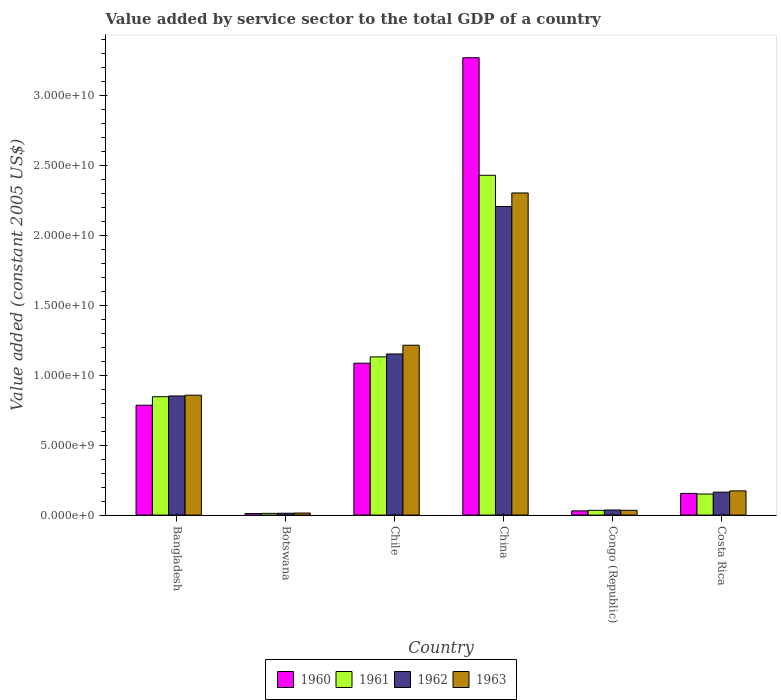How many different coloured bars are there?
Your answer should be compact. 4. How many groups of bars are there?
Provide a succinct answer. 6. Are the number of bars per tick equal to the number of legend labels?
Make the answer very short. Yes. In how many cases, is the number of bars for a given country not equal to the number of legend labels?
Give a very brief answer. 0. What is the value added by service sector in 1963 in Costa Rica?
Provide a short and direct response. 1.73e+09. Across all countries, what is the maximum value added by service sector in 1962?
Your answer should be compact. 2.21e+1. Across all countries, what is the minimum value added by service sector in 1961?
Ensure brevity in your answer.  1.22e+08. In which country was the value added by service sector in 1960 minimum?
Your answer should be very brief. Botswana. What is the total value added by service sector in 1960 in the graph?
Your response must be concise. 5.34e+1. What is the difference between the value added by service sector in 1960 in China and that in Congo (Republic)?
Keep it short and to the point. 3.24e+1. What is the difference between the value added by service sector in 1962 in Chile and the value added by service sector in 1963 in Costa Rica?
Offer a very short reply. 9.80e+09. What is the average value added by service sector in 1961 per country?
Give a very brief answer. 7.68e+09. What is the difference between the value added by service sector of/in 1963 and value added by service sector of/in 1960 in Congo (Republic)?
Ensure brevity in your answer.  4.05e+07. What is the ratio of the value added by service sector in 1960 in Chile to that in China?
Make the answer very short. 0.33. What is the difference between the highest and the second highest value added by service sector in 1960?
Your answer should be compact. -2.19e+1. What is the difference between the highest and the lowest value added by service sector in 1963?
Your answer should be very brief. 2.29e+1. In how many countries, is the value added by service sector in 1960 greater than the average value added by service sector in 1960 taken over all countries?
Provide a succinct answer. 2. Is it the case that in every country, the sum of the value added by service sector in 1962 and value added by service sector in 1963 is greater than the sum of value added by service sector in 1960 and value added by service sector in 1961?
Your answer should be very brief. No. What is the difference between two consecutive major ticks on the Y-axis?
Give a very brief answer. 5.00e+09. Are the values on the major ticks of Y-axis written in scientific E-notation?
Offer a very short reply. Yes. Does the graph contain any zero values?
Your response must be concise. No. Does the graph contain grids?
Your response must be concise. No. Where does the legend appear in the graph?
Make the answer very short. Bottom center. What is the title of the graph?
Offer a terse response. Value added by service sector to the total GDP of a country. Does "1999" appear as one of the legend labels in the graph?
Keep it short and to the point. No. What is the label or title of the Y-axis?
Offer a very short reply. Value added (constant 2005 US$). What is the Value added (constant 2005 US$) of 1960 in Bangladesh?
Your answer should be very brief. 7.86e+09. What is the Value added (constant 2005 US$) in 1961 in Bangladesh?
Make the answer very short. 8.47e+09. What is the Value added (constant 2005 US$) of 1962 in Bangladesh?
Your answer should be compact. 8.52e+09. What is the Value added (constant 2005 US$) of 1963 in Bangladesh?
Your answer should be very brief. 8.58e+09. What is the Value added (constant 2005 US$) in 1960 in Botswana?
Provide a short and direct response. 1.11e+08. What is the Value added (constant 2005 US$) in 1961 in Botswana?
Keep it short and to the point. 1.22e+08. What is the Value added (constant 2005 US$) in 1962 in Botswana?
Provide a succinct answer. 1.32e+08. What is the Value added (constant 2005 US$) of 1963 in Botswana?
Offer a terse response. 1.45e+08. What is the Value added (constant 2005 US$) in 1960 in Chile?
Make the answer very short. 1.09e+1. What is the Value added (constant 2005 US$) of 1961 in Chile?
Offer a terse response. 1.13e+1. What is the Value added (constant 2005 US$) of 1962 in Chile?
Give a very brief answer. 1.15e+1. What is the Value added (constant 2005 US$) in 1963 in Chile?
Make the answer very short. 1.22e+1. What is the Value added (constant 2005 US$) in 1960 in China?
Give a very brief answer. 3.27e+1. What is the Value added (constant 2005 US$) in 1961 in China?
Keep it short and to the point. 2.43e+1. What is the Value added (constant 2005 US$) of 1962 in China?
Make the answer very short. 2.21e+1. What is the Value added (constant 2005 US$) of 1963 in China?
Your response must be concise. 2.30e+1. What is the Value added (constant 2005 US$) of 1960 in Congo (Republic)?
Your response must be concise. 3.02e+08. What is the Value added (constant 2005 US$) of 1961 in Congo (Republic)?
Offer a terse response. 3.39e+08. What is the Value added (constant 2005 US$) of 1962 in Congo (Republic)?
Your response must be concise. 3.64e+08. What is the Value added (constant 2005 US$) in 1963 in Congo (Republic)?
Your response must be concise. 3.42e+08. What is the Value added (constant 2005 US$) of 1960 in Costa Rica?
Provide a short and direct response. 1.55e+09. What is the Value added (constant 2005 US$) of 1961 in Costa Rica?
Make the answer very short. 1.51e+09. What is the Value added (constant 2005 US$) in 1962 in Costa Rica?
Your answer should be very brief. 1.64e+09. What is the Value added (constant 2005 US$) in 1963 in Costa Rica?
Provide a succinct answer. 1.73e+09. Across all countries, what is the maximum Value added (constant 2005 US$) of 1960?
Give a very brief answer. 3.27e+1. Across all countries, what is the maximum Value added (constant 2005 US$) of 1961?
Your answer should be very brief. 2.43e+1. Across all countries, what is the maximum Value added (constant 2005 US$) in 1962?
Your response must be concise. 2.21e+1. Across all countries, what is the maximum Value added (constant 2005 US$) of 1963?
Offer a very short reply. 2.30e+1. Across all countries, what is the minimum Value added (constant 2005 US$) of 1960?
Your response must be concise. 1.11e+08. Across all countries, what is the minimum Value added (constant 2005 US$) in 1961?
Your response must be concise. 1.22e+08. Across all countries, what is the minimum Value added (constant 2005 US$) of 1962?
Provide a short and direct response. 1.32e+08. Across all countries, what is the minimum Value added (constant 2005 US$) in 1963?
Provide a succinct answer. 1.45e+08. What is the total Value added (constant 2005 US$) of 1960 in the graph?
Your answer should be very brief. 5.34e+1. What is the total Value added (constant 2005 US$) of 1961 in the graph?
Provide a short and direct response. 4.61e+1. What is the total Value added (constant 2005 US$) in 1962 in the graph?
Your response must be concise. 4.43e+1. What is the total Value added (constant 2005 US$) in 1963 in the graph?
Ensure brevity in your answer.  4.60e+1. What is the difference between the Value added (constant 2005 US$) in 1960 in Bangladesh and that in Botswana?
Provide a succinct answer. 7.75e+09. What is the difference between the Value added (constant 2005 US$) of 1961 in Bangladesh and that in Botswana?
Provide a succinct answer. 8.35e+09. What is the difference between the Value added (constant 2005 US$) in 1962 in Bangladesh and that in Botswana?
Give a very brief answer. 8.39e+09. What is the difference between the Value added (constant 2005 US$) in 1963 in Bangladesh and that in Botswana?
Offer a terse response. 8.43e+09. What is the difference between the Value added (constant 2005 US$) of 1960 in Bangladesh and that in Chile?
Your answer should be very brief. -3.01e+09. What is the difference between the Value added (constant 2005 US$) in 1961 in Bangladesh and that in Chile?
Make the answer very short. -2.85e+09. What is the difference between the Value added (constant 2005 US$) of 1962 in Bangladesh and that in Chile?
Ensure brevity in your answer.  -3.00e+09. What is the difference between the Value added (constant 2005 US$) in 1963 in Bangladesh and that in Chile?
Your answer should be very brief. -3.58e+09. What is the difference between the Value added (constant 2005 US$) of 1960 in Bangladesh and that in China?
Your answer should be very brief. -2.49e+1. What is the difference between the Value added (constant 2005 US$) in 1961 in Bangladesh and that in China?
Provide a short and direct response. -1.58e+1. What is the difference between the Value added (constant 2005 US$) in 1962 in Bangladesh and that in China?
Make the answer very short. -1.36e+1. What is the difference between the Value added (constant 2005 US$) in 1963 in Bangladesh and that in China?
Offer a very short reply. -1.45e+1. What is the difference between the Value added (constant 2005 US$) in 1960 in Bangladesh and that in Congo (Republic)?
Provide a short and direct response. 7.56e+09. What is the difference between the Value added (constant 2005 US$) in 1961 in Bangladesh and that in Congo (Republic)?
Provide a succinct answer. 8.13e+09. What is the difference between the Value added (constant 2005 US$) of 1962 in Bangladesh and that in Congo (Republic)?
Offer a very short reply. 8.16e+09. What is the difference between the Value added (constant 2005 US$) in 1963 in Bangladesh and that in Congo (Republic)?
Provide a succinct answer. 8.24e+09. What is the difference between the Value added (constant 2005 US$) in 1960 in Bangladesh and that in Costa Rica?
Keep it short and to the point. 6.31e+09. What is the difference between the Value added (constant 2005 US$) in 1961 in Bangladesh and that in Costa Rica?
Give a very brief answer. 6.96e+09. What is the difference between the Value added (constant 2005 US$) of 1962 in Bangladesh and that in Costa Rica?
Keep it short and to the point. 6.88e+09. What is the difference between the Value added (constant 2005 US$) in 1963 in Bangladesh and that in Costa Rica?
Offer a very short reply. 6.85e+09. What is the difference between the Value added (constant 2005 US$) in 1960 in Botswana and that in Chile?
Ensure brevity in your answer.  -1.08e+1. What is the difference between the Value added (constant 2005 US$) of 1961 in Botswana and that in Chile?
Make the answer very short. -1.12e+1. What is the difference between the Value added (constant 2005 US$) of 1962 in Botswana and that in Chile?
Give a very brief answer. -1.14e+1. What is the difference between the Value added (constant 2005 US$) in 1963 in Botswana and that in Chile?
Provide a short and direct response. -1.20e+1. What is the difference between the Value added (constant 2005 US$) of 1960 in Botswana and that in China?
Provide a short and direct response. -3.26e+1. What is the difference between the Value added (constant 2005 US$) of 1961 in Botswana and that in China?
Give a very brief answer. -2.42e+1. What is the difference between the Value added (constant 2005 US$) in 1962 in Botswana and that in China?
Offer a terse response. -2.19e+1. What is the difference between the Value added (constant 2005 US$) in 1963 in Botswana and that in China?
Keep it short and to the point. -2.29e+1. What is the difference between the Value added (constant 2005 US$) of 1960 in Botswana and that in Congo (Republic)?
Make the answer very short. -1.91e+08. What is the difference between the Value added (constant 2005 US$) of 1961 in Botswana and that in Congo (Republic)?
Your answer should be compact. -2.17e+08. What is the difference between the Value added (constant 2005 US$) of 1962 in Botswana and that in Congo (Republic)?
Provide a short and direct response. -2.32e+08. What is the difference between the Value added (constant 2005 US$) of 1963 in Botswana and that in Congo (Republic)?
Ensure brevity in your answer.  -1.97e+08. What is the difference between the Value added (constant 2005 US$) in 1960 in Botswana and that in Costa Rica?
Offer a very short reply. -1.44e+09. What is the difference between the Value added (constant 2005 US$) in 1961 in Botswana and that in Costa Rica?
Offer a very short reply. -1.38e+09. What is the difference between the Value added (constant 2005 US$) of 1962 in Botswana and that in Costa Rica?
Ensure brevity in your answer.  -1.51e+09. What is the difference between the Value added (constant 2005 US$) in 1963 in Botswana and that in Costa Rica?
Give a very brief answer. -1.59e+09. What is the difference between the Value added (constant 2005 US$) of 1960 in Chile and that in China?
Your response must be concise. -2.19e+1. What is the difference between the Value added (constant 2005 US$) in 1961 in Chile and that in China?
Give a very brief answer. -1.30e+1. What is the difference between the Value added (constant 2005 US$) of 1962 in Chile and that in China?
Make the answer very short. -1.05e+1. What is the difference between the Value added (constant 2005 US$) in 1963 in Chile and that in China?
Your answer should be very brief. -1.09e+1. What is the difference between the Value added (constant 2005 US$) in 1960 in Chile and that in Congo (Republic)?
Offer a terse response. 1.06e+1. What is the difference between the Value added (constant 2005 US$) in 1961 in Chile and that in Congo (Republic)?
Keep it short and to the point. 1.10e+1. What is the difference between the Value added (constant 2005 US$) of 1962 in Chile and that in Congo (Republic)?
Your answer should be very brief. 1.12e+1. What is the difference between the Value added (constant 2005 US$) in 1963 in Chile and that in Congo (Republic)?
Offer a terse response. 1.18e+1. What is the difference between the Value added (constant 2005 US$) in 1960 in Chile and that in Costa Rica?
Offer a terse response. 9.31e+09. What is the difference between the Value added (constant 2005 US$) in 1961 in Chile and that in Costa Rica?
Offer a very short reply. 9.81e+09. What is the difference between the Value added (constant 2005 US$) in 1962 in Chile and that in Costa Rica?
Offer a very short reply. 9.89e+09. What is the difference between the Value added (constant 2005 US$) in 1963 in Chile and that in Costa Rica?
Provide a short and direct response. 1.04e+1. What is the difference between the Value added (constant 2005 US$) of 1960 in China and that in Congo (Republic)?
Offer a very short reply. 3.24e+1. What is the difference between the Value added (constant 2005 US$) in 1961 in China and that in Congo (Republic)?
Make the answer very short. 2.40e+1. What is the difference between the Value added (constant 2005 US$) of 1962 in China and that in Congo (Republic)?
Your answer should be very brief. 2.17e+1. What is the difference between the Value added (constant 2005 US$) of 1963 in China and that in Congo (Republic)?
Your answer should be compact. 2.27e+1. What is the difference between the Value added (constant 2005 US$) in 1960 in China and that in Costa Rica?
Your answer should be very brief. 3.12e+1. What is the difference between the Value added (constant 2005 US$) of 1961 in China and that in Costa Rica?
Offer a terse response. 2.28e+1. What is the difference between the Value added (constant 2005 US$) in 1962 in China and that in Costa Rica?
Keep it short and to the point. 2.04e+1. What is the difference between the Value added (constant 2005 US$) in 1963 in China and that in Costa Rica?
Make the answer very short. 2.13e+1. What is the difference between the Value added (constant 2005 US$) in 1960 in Congo (Republic) and that in Costa Rica?
Your answer should be compact. -1.25e+09. What is the difference between the Value added (constant 2005 US$) of 1961 in Congo (Republic) and that in Costa Rica?
Provide a succinct answer. -1.17e+09. What is the difference between the Value added (constant 2005 US$) in 1962 in Congo (Republic) and that in Costa Rica?
Keep it short and to the point. -1.28e+09. What is the difference between the Value added (constant 2005 US$) in 1963 in Congo (Republic) and that in Costa Rica?
Ensure brevity in your answer.  -1.39e+09. What is the difference between the Value added (constant 2005 US$) in 1960 in Bangladesh and the Value added (constant 2005 US$) in 1961 in Botswana?
Your answer should be compact. 7.74e+09. What is the difference between the Value added (constant 2005 US$) in 1960 in Bangladesh and the Value added (constant 2005 US$) in 1962 in Botswana?
Offer a very short reply. 7.73e+09. What is the difference between the Value added (constant 2005 US$) of 1960 in Bangladesh and the Value added (constant 2005 US$) of 1963 in Botswana?
Your answer should be very brief. 7.72e+09. What is the difference between the Value added (constant 2005 US$) in 1961 in Bangladesh and the Value added (constant 2005 US$) in 1962 in Botswana?
Provide a short and direct response. 8.34e+09. What is the difference between the Value added (constant 2005 US$) of 1961 in Bangladesh and the Value added (constant 2005 US$) of 1963 in Botswana?
Keep it short and to the point. 8.32e+09. What is the difference between the Value added (constant 2005 US$) of 1962 in Bangladesh and the Value added (constant 2005 US$) of 1963 in Botswana?
Provide a succinct answer. 8.38e+09. What is the difference between the Value added (constant 2005 US$) of 1960 in Bangladesh and the Value added (constant 2005 US$) of 1961 in Chile?
Your answer should be compact. -3.46e+09. What is the difference between the Value added (constant 2005 US$) in 1960 in Bangladesh and the Value added (constant 2005 US$) in 1962 in Chile?
Provide a succinct answer. -3.67e+09. What is the difference between the Value added (constant 2005 US$) of 1960 in Bangladesh and the Value added (constant 2005 US$) of 1963 in Chile?
Ensure brevity in your answer.  -4.29e+09. What is the difference between the Value added (constant 2005 US$) of 1961 in Bangladesh and the Value added (constant 2005 US$) of 1962 in Chile?
Provide a succinct answer. -3.06e+09. What is the difference between the Value added (constant 2005 US$) in 1961 in Bangladesh and the Value added (constant 2005 US$) in 1963 in Chile?
Make the answer very short. -3.68e+09. What is the difference between the Value added (constant 2005 US$) in 1962 in Bangladesh and the Value added (constant 2005 US$) in 1963 in Chile?
Ensure brevity in your answer.  -3.63e+09. What is the difference between the Value added (constant 2005 US$) in 1960 in Bangladesh and the Value added (constant 2005 US$) in 1961 in China?
Provide a succinct answer. -1.65e+1. What is the difference between the Value added (constant 2005 US$) of 1960 in Bangladesh and the Value added (constant 2005 US$) of 1962 in China?
Make the answer very short. -1.42e+1. What is the difference between the Value added (constant 2005 US$) in 1960 in Bangladesh and the Value added (constant 2005 US$) in 1963 in China?
Your answer should be very brief. -1.52e+1. What is the difference between the Value added (constant 2005 US$) in 1961 in Bangladesh and the Value added (constant 2005 US$) in 1962 in China?
Offer a very short reply. -1.36e+1. What is the difference between the Value added (constant 2005 US$) of 1961 in Bangladesh and the Value added (constant 2005 US$) of 1963 in China?
Ensure brevity in your answer.  -1.46e+1. What is the difference between the Value added (constant 2005 US$) in 1962 in Bangladesh and the Value added (constant 2005 US$) in 1963 in China?
Make the answer very short. -1.45e+1. What is the difference between the Value added (constant 2005 US$) in 1960 in Bangladesh and the Value added (constant 2005 US$) in 1961 in Congo (Republic)?
Give a very brief answer. 7.52e+09. What is the difference between the Value added (constant 2005 US$) in 1960 in Bangladesh and the Value added (constant 2005 US$) in 1962 in Congo (Republic)?
Make the answer very short. 7.50e+09. What is the difference between the Value added (constant 2005 US$) in 1960 in Bangladesh and the Value added (constant 2005 US$) in 1963 in Congo (Republic)?
Your answer should be very brief. 7.52e+09. What is the difference between the Value added (constant 2005 US$) of 1961 in Bangladesh and the Value added (constant 2005 US$) of 1962 in Congo (Republic)?
Ensure brevity in your answer.  8.11e+09. What is the difference between the Value added (constant 2005 US$) in 1961 in Bangladesh and the Value added (constant 2005 US$) in 1963 in Congo (Republic)?
Offer a terse response. 8.13e+09. What is the difference between the Value added (constant 2005 US$) of 1962 in Bangladesh and the Value added (constant 2005 US$) of 1963 in Congo (Republic)?
Your answer should be very brief. 8.18e+09. What is the difference between the Value added (constant 2005 US$) of 1960 in Bangladesh and the Value added (constant 2005 US$) of 1961 in Costa Rica?
Make the answer very short. 6.36e+09. What is the difference between the Value added (constant 2005 US$) of 1960 in Bangladesh and the Value added (constant 2005 US$) of 1962 in Costa Rica?
Keep it short and to the point. 6.22e+09. What is the difference between the Value added (constant 2005 US$) in 1960 in Bangladesh and the Value added (constant 2005 US$) in 1963 in Costa Rica?
Your answer should be very brief. 6.13e+09. What is the difference between the Value added (constant 2005 US$) of 1961 in Bangladesh and the Value added (constant 2005 US$) of 1962 in Costa Rica?
Offer a terse response. 6.83e+09. What is the difference between the Value added (constant 2005 US$) in 1961 in Bangladesh and the Value added (constant 2005 US$) in 1963 in Costa Rica?
Make the answer very short. 6.74e+09. What is the difference between the Value added (constant 2005 US$) of 1962 in Bangladesh and the Value added (constant 2005 US$) of 1963 in Costa Rica?
Ensure brevity in your answer.  6.79e+09. What is the difference between the Value added (constant 2005 US$) in 1960 in Botswana and the Value added (constant 2005 US$) in 1961 in Chile?
Your response must be concise. -1.12e+1. What is the difference between the Value added (constant 2005 US$) in 1960 in Botswana and the Value added (constant 2005 US$) in 1962 in Chile?
Make the answer very short. -1.14e+1. What is the difference between the Value added (constant 2005 US$) of 1960 in Botswana and the Value added (constant 2005 US$) of 1963 in Chile?
Your answer should be compact. -1.20e+1. What is the difference between the Value added (constant 2005 US$) of 1961 in Botswana and the Value added (constant 2005 US$) of 1962 in Chile?
Offer a very short reply. -1.14e+1. What is the difference between the Value added (constant 2005 US$) in 1961 in Botswana and the Value added (constant 2005 US$) in 1963 in Chile?
Your answer should be very brief. -1.20e+1. What is the difference between the Value added (constant 2005 US$) in 1962 in Botswana and the Value added (constant 2005 US$) in 1963 in Chile?
Your answer should be very brief. -1.20e+1. What is the difference between the Value added (constant 2005 US$) of 1960 in Botswana and the Value added (constant 2005 US$) of 1961 in China?
Keep it short and to the point. -2.42e+1. What is the difference between the Value added (constant 2005 US$) of 1960 in Botswana and the Value added (constant 2005 US$) of 1962 in China?
Give a very brief answer. -2.20e+1. What is the difference between the Value added (constant 2005 US$) of 1960 in Botswana and the Value added (constant 2005 US$) of 1963 in China?
Provide a succinct answer. -2.29e+1. What is the difference between the Value added (constant 2005 US$) in 1961 in Botswana and the Value added (constant 2005 US$) in 1962 in China?
Keep it short and to the point. -2.20e+1. What is the difference between the Value added (constant 2005 US$) in 1961 in Botswana and the Value added (constant 2005 US$) in 1963 in China?
Offer a terse response. -2.29e+1. What is the difference between the Value added (constant 2005 US$) of 1962 in Botswana and the Value added (constant 2005 US$) of 1963 in China?
Ensure brevity in your answer.  -2.29e+1. What is the difference between the Value added (constant 2005 US$) of 1960 in Botswana and the Value added (constant 2005 US$) of 1961 in Congo (Republic)?
Ensure brevity in your answer.  -2.28e+08. What is the difference between the Value added (constant 2005 US$) of 1960 in Botswana and the Value added (constant 2005 US$) of 1962 in Congo (Republic)?
Provide a short and direct response. -2.53e+08. What is the difference between the Value added (constant 2005 US$) of 1960 in Botswana and the Value added (constant 2005 US$) of 1963 in Congo (Republic)?
Keep it short and to the point. -2.31e+08. What is the difference between the Value added (constant 2005 US$) of 1961 in Botswana and the Value added (constant 2005 US$) of 1962 in Congo (Republic)?
Offer a very short reply. -2.42e+08. What is the difference between the Value added (constant 2005 US$) of 1961 in Botswana and the Value added (constant 2005 US$) of 1963 in Congo (Republic)?
Give a very brief answer. -2.20e+08. What is the difference between the Value added (constant 2005 US$) in 1962 in Botswana and the Value added (constant 2005 US$) in 1963 in Congo (Republic)?
Your response must be concise. -2.10e+08. What is the difference between the Value added (constant 2005 US$) in 1960 in Botswana and the Value added (constant 2005 US$) in 1961 in Costa Rica?
Your answer should be very brief. -1.39e+09. What is the difference between the Value added (constant 2005 US$) of 1960 in Botswana and the Value added (constant 2005 US$) of 1962 in Costa Rica?
Your response must be concise. -1.53e+09. What is the difference between the Value added (constant 2005 US$) in 1960 in Botswana and the Value added (constant 2005 US$) in 1963 in Costa Rica?
Provide a short and direct response. -1.62e+09. What is the difference between the Value added (constant 2005 US$) of 1961 in Botswana and the Value added (constant 2005 US$) of 1962 in Costa Rica?
Make the answer very short. -1.52e+09. What is the difference between the Value added (constant 2005 US$) in 1961 in Botswana and the Value added (constant 2005 US$) in 1963 in Costa Rica?
Offer a terse response. -1.61e+09. What is the difference between the Value added (constant 2005 US$) of 1962 in Botswana and the Value added (constant 2005 US$) of 1963 in Costa Rica?
Offer a terse response. -1.60e+09. What is the difference between the Value added (constant 2005 US$) of 1960 in Chile and the Value added (constant 2005 US$) of 1961 in China?
Offer a terse response. -1.34e+1. What is the difference between the Value added (constant 2005 US$) in 1960 in Chile and the Value added (constant 2005 US$) in 1962 in China?
Provide a succinct answer. -1.12e+1. What is the difference between the Value added (constant 2005 US$) of 1960 in Chile and the Value added (constant 2005 US$) of 1963 in China?
Your response must be concise. -1.22e+1. What is the difference between the Value added (constant 2005 US$) of 1961 in Chile and the Value added (constant 2005 US$) of 1962 in China?
Make the answer very short. -1.08e+1. What is the difference between the Value added (constant 2005 US$) of 1961 in Chile and the Value added (constant 2005 US$) of 1963 in China?
Offer a very short reply. -1.17e+1. What is the difference between the Value added (constant 2005 US$) in 1962 in Chile and the Value added (constant 2005 US$) in 1963 in China?
Keep it short and to the point. -1.15e+1. What is the difference between the Value added (constant 2005 US$) of 1960 in Chile and the Value added (constant 2005 US$) of 1961 in Congo (Republic)?
Make the answer very short. 1.05e+1. What is the difference between the Value added (constant 2005 US$) in 1960 in Chile and the Value added (constant 2005 US$) in 1962 in Congo (Republic)?
Your answer should be compact. 1.05e+1. What is the difference between the Value added (constant 2005 US$) in 1960 in Chile and the Value added (constant 2005 US$) in 1963 in Congo (Republic)?
Your answer should be compact. 1.05e+1. What is the difference between the Value added (constant 2005 US$) of 1961 in Chile and the Value added (constant 2005 US$) of 1962 in Congo (Republic)?
Provide a succinct answer. 1.10e+1. What is the difference between the Value added (constant 2005 US$) in 1961 in Chile and the Value added (constant 2005 US$) in 1963 in Congo (Republic)?
Make the answer very short. 1.10e+1. What is the difference between the Value added (constant 2005 US$) in 1962 in Chile and the Value added (constant 2005 US$) in 1963 in Congo (Republic)?
Your answer should be compact. 1.12e+1. What is the difference between the Value added (constant 2005 US$) of 1960 in Chile and the Value added (constant 2005 US$) of 1961 in Costa Rica?
Ensure brevity in your answer.  9.36e+09. What is the difference between the Value added (constant 2005 US$) of 1960 in Chile and the Value added (constant 2005 US$) of 1962 in Costa Rica?
Provide a succinct answer. 9.23e+09. What is the difference between the Value added (constant 2005 US$) in 1960 in Chile and the Value added (constant 2005 US$) in 1963 in Costa Rica?
Make the answer very short. 9.14e+09. What is the difference between the Value added (constant 2005 US$) of 1961 in Chile and the Value added (constant 2005 US$) of 1962 in Costa Rica?
Your answer should be very brief. 9.68e+09. What is the difference between the Value added (constant 2005 US$) in 1961 in Chile and the Value added (constant 2005 US$) in 1963 in Costa Rica?
Offer a very short reply. 9.59e+09. What is the difference between the Value added (constant 2005 US$) of 1962 in Chile and the Value added (constant 2005 US$) of 1963 in Costa Rica?
Give a very brief answer. 9.80e+09. What is the difference between the Value added (constant 2005 US$) of 1960 in China and the Value added (constant 2005 US$) of 1961 in Congo (Republic)?
Your response must be concise. 3.24e+1. What is the difference between the Value added (constant 2005 US$) of 1960 in China and the Value added (constant 2005 US$) of 1962 in Congo (Republic)?
Provide a succinct answer. 3.24e+1. What is the difference between the Value added (constant 2005 US$) in 1960 in China and the Value added (constant 2005 US$) in 1963 in Congo (Republic)?
Your response must be concise. 3.24e+1. What is the difference between the Value added (constant 2005 US$) of 1961 in China and the Value added (constant 2005 US$) of 1962 in Congo (Republic)?
Make the answer very short. 2.39e+1. What is the difference between the Value added (constant 2005 US$) in 1961 in China and the Value added (constant 2005 US$) in 1963 in Congo (Republic)?
Your answer should be compact. 2.40e+1. What is the difference between the Value added (constant 2005 US$) of 1962 in China and the Value added (constant 2005 US$) of 1963 in Congo (Republic)?
Provide a succinct answer. 2.17e+1. What is the difference between the Value added (constant 2005 US$) in 1960 in China and the Value added (constant 2005 US$) in 1961 in Costa Rica?
Provide a succinct answer. 3.12e+1. What is the difference between the Value added (constant 2005 US$) of 1960 in China and the Value added (constant 2005 US$) of 1962 in Costa Rica?
Ensure brevity in your answer.  3.11e+1. What is the difference between the Value added (constant 2005 US$) in 1960 in China and the Value added (constant 2005 US$) in 1963 in Costa Rica?
Provide a short and direct response. 3.10e+1. What is the difference between the Value added (constant 2005 US$) of 1961 in China and the Value added (constant 2005 US$) of 1962 in Costa Rica?
Provide a short and direct response. 2.27e+1. What is the difference between the Value added (constant 2005 US$) of 1961 in China and the Value added (constant 2005 US$) of 1963 in Costa Rica?
Keep it short and to the point. 2.26e+1. What is the difference between the Value added (constant 2005 US$) of 1962 in China and the Value added (constant 2005 US$) of 1963 in Costa Rica?
Provide a succinct answer. 2.03e+1. What is the difference between the Value added (constant 2005 US$) of 1960 in Congo (Republic) and the Value added (constant 2005 US$) of 1961 in Costa Rica?
Your response must be concise. -1.20e+09. What is the difference between the Value added (constant 2005 US$) in 1960 in Congo (Republic) and the Value added (constant 2005 US$) in 1962 in Costa Rica?
Your response must be concise. -1.34e+09. What is the difference between the Value added (constant 2005 US$) of 1960 in Congo (Republic) and the Value added (constant 2005 US$) of 1963 in Costa Rica?
Your answer should be compact. -1.43e+09. What is the difference between the Value added (constant 2005 US$) in 1961 in Congo (Republic) and the Value added (constant 2005 US$) in 1962 in Costa Rica?
Ensure brevity in your answer.  -1.30e+09. What is the difference between the Value added (constant 2005 US$) in 1961 in Congo (Republic) and the Value added (constant 2005 US$) in 1963 in Costa Rica?
Offer a terse response. -1.39e+09. What is the difference between the Value added (constant 2005 US$) of 1962 in Congo (Republic) and the Value added (constant 2005 US$) of 1963 in Costa Rica?
Ensure brevity in your answer.  -1.37e+09. What is the average Value added (constant 2005 US$) in 1960 per country?
Keep it short and to the point. 8.90e+09. What is the average Value added (constant 2005 US$) in 1961 per country?
Your answer should be compact. 7.68e+09. What is the average Value added (constant 2005 US$) in 1962 per country?
Keep it short and to the point. 7.38e+09. What is the average Value added (constant 2005 US$) in 1963 per country?
Give a very brief answer. 7.67e+09. What is the difference between the Value added (constant 2005 US$) in 1960 and Value added (constant 2005 US$) in 1961 in Bangladesh?
Your answer should be compact. -6.09e+08. What is the difference between the Value added (constant 2005 US$) in 1960 and Value added (constant 2005 US$) in 1962 in Bangladesh?
Keep it short and to the point. -6.62e+08. What is the difference between the Value added (constant 2005 US$) in 1960 and Value added (constant 2005 US$) in 1963 in Bangladesh?
Offer a very short reply. -7.16e+08. What is the difference between the Value added (constant 2005 US$) of 1961 and Value added (constant 2005 US$) of 1962 in Bangladesh?
Offer a terse response. -5.33e+07. What is the difference between the Value added (constant 2005 US$) of 1961 and Value added (constant 2005 US$) of 1963 in Bangladesh?
Provide a succinct answer. -1.08e+08. What is the difference between the Value added (constant 2005 US$) in 1962 and Value added (constant 2005 US$) in 1963 in Bangladesh?
Your response must be concise. -5.45e+07. What is the difference between the Value added (constant 2005 US$) of 1960 and Value added (constant 2005 US$) of 1961 in Botswana?
Offer a very short reply. -1.12e+07. What is the difference between the Value added (constant 2005 US$) in 1960 and Value added (constant 2005 US$) in 1962 in Botswana?
Ensure brevity in your answer.  -2.17e+07. What is the difference between the Value added (constant 2005 US$) of 1960 and Value added (constant 2005 US$) of 1963 in Botswana?
Provide a short and direct response. -3.45e+07. What is the difference between the Value added (constant 2005 US$) of 1961 and Value added (constant 2005 US$) of 1962 in Botswana?
Provide a short and direct response. -1.05e+07. What is the difference between the Value added (constant 2005 US$) of 1961 and Value added (constant 2005 US$) of 1963 in Botswana?
Ensure brevity in your answer.  -2.33e+07. What is the difference between the Value added (constant 2005 US$) of 1962 and Value added (constant 2005 US$) of 1963 in Botswana?
Give a very brief answer. -1.28e+07. What is the difference between the Value added (constant 2005 US$) of 1960 and Value added (constant 2005 US$) of 1961 in Chile?
Provide a short and direct response. -4.53e+08. What is the difference between the Value added (constant 2005 US$) in 1960 and Value added (constant 2005 US$) in 1962 in Chile?
Ensure brevity in your answer.  -6.60e+08. What is the difference between the Value added (constant 2005 US$) in 1960 and Value added (constant 2005 US$) in 1963 in Chile?
Provide a short and direct response. -1.29e+09. What is the difference between the Value added (constant 2005 US$) of 1961 and Value added (constant 2005 US$) of 1962 in Chile?
Your answer should be compact. -2.07e+08. What is the difference between the Value added (constant 2005 US$) in 1961 and Value added (constant 2005 US$) in 1963 in Chile?
Provide a succinct answer. -8.32e+08. What is the difference between the Value added (constant 2005 US$) in 1962 and Value added (constant 2005 US$) in 1963 in Chile?
Your answer should be very brief. -6.25e+08. What is the difference between the Value added (constant 2005 US$) of 1960 and Value added (constant 2005 US$) of 1961 in China?
Offer a terse response. 8.41e+09. What is the difference between the Value added (constant 2005 US$) in 1960 and Value added (constant 2005 US$) in 1962 in China?
Ensure brevity in your answer.  1.06e+1. What is the difference between the Value added (constant 2005 US$) in 1960 and Value added (constant 2005 US$) in 1963 in China?
Your response must be concise. 9.68e+09. What is the difference between the Value added (constant 2005 US$) of 1961 and Value added (constant 2005 US$) of 1962 in China?
Provide a succinct answer. 2.24e+09. What is the difference between the Value added (constant 2005 US$) of 1961 and Value added (constant 2005 US$) of 1963 in China?
Keep it short and to the point. 1.27e+09. What is the difference between the Value added (constant 2005 US$) of 1962 and Value added (constant 2005 US$) of 1963 in China?
Provide a short and direct response. -9.71e+08. What is the difference between the Value added (constant 2005 US$) in 1960 and Value added (constant 2005 US$) in 1961 in Congo (Republic)?
Your response must be concise. -3.74e+07. What is the difference between the Value added (constant 2005 US$) of 1960 and Value added (constant 2005 US$) of 1962 in Congo (Republic)?
Offer a very short reply. -6.23e+07. What is the difference between the Value added (constant 2005 US$) of 1960 and Value added (constant 2005 US$) of 1963 in Congo (Republic)?
Your answer should be very brief. -4.05e+07. What is the difference between the Value added (constant 2005 US$) in 1961 and Value added (constant 2005 US$) in 1962 in Congo (Republic)?
Keep it short and to the point. -2.49e+07. What is the difference between the Value added (constant 2005 US$) of 1961 and Value added (constant 2005 US$) of 1963 in Congo (Republic)?
Keep it short and to the point. -3.09e+06. What is the difference between the Value added (constant 2005 US$) in 1962 and Value added (constant 2005 US$) in 1963 in Congo (Republic)?
Ensure brevity in your answer.  2.18e+07. What is the difference between the Value added (constant 2005 US$) in 1960 and Value added (constant 2005 US$) in 1961 in Costa Rica?
Your answer should be compact. 4.72e+07. What is the difference between the Value added (constant 2005 US$) in 1960 and Value added (constant 2005 US$) in 1962 in Costa Rica?
Offer a very short reply. -8.87e+07. What is the difference between the Value added (constant 2005 US$) in 1960 and Value added (constant 2005 US$) in 1963 in Costa Rica?
Ensure brevity in your answer.  -1.78e+08. What is the difference between the Value added (constant 2005 US$) in 1961 and Value added (constant 2005 US$) in 1962 in Costa Rica?
Give a very brief answer. -1.36e+08. What is the difference between the Value added (constant 2005 US$) of 1961 and Value added (constant 2005 US$) of 1963 in Costa Rica?
Offer a terse response. -2.25e+08. What is the difference between the Value added (constant 2005 US$) of 1962 and Value added (constant 2005 US$) of 1963 in Costa Rica?
Provide a short and direct response. -8.94e+07. What is the ratio of the Value added (constant 2005 US$) of 1960 in Bangladesh to that in Botswana?
Offer a very short reply. 71.09. What is the ratio of the Value added (constant 2005 US$) of 1961 in Bangladesh to that in Botswana?
Make the answer very short. 69.55. What is the ratio of the Value added (constant 2005 US$) in 1962 in Bangladesh to that in Botswana?
Offer a very short reply. 64.43. What is the ratio of the Value added (constant 2005 US$) of 1963 in Bangladesh to that in Botswana?
Your answer should be very brief. 59.12. What is the ratio of the Value added (constant 2005 US$) of 1960 in Bangladesh to that in Chile?
Your response must be concise. 0.72. What is the ratio of the Value added (constant 2005 US$) in 1961 in Bangladesh to that in Chile?
Keep it short and to the point. 0.75. What is the ratio of the Value added (constant 2005 US$) of 1962 in Bangladesh to that in Chile?
Keep it short and to the point. 0.74. What is the ratio of the Value added (constant 2005 US$) of 1963 in Bangladesh to that in Chile?
Your response must be concise. 0.71. What is the ratio of the Value added (constant 2005 US$) in 1960 in Bangladesh to that in China?
Provide a short and direct response. 0.24. What is the ratio of the Value added (constant 2005 US$) in 1961 in Bangladesh to that in China?
Your response must be concise. 0.35. What is the ratio of the Value added (constant 2005 US$) in 1962 in Bangladesh to that in China?
Offer a very short reply. 0.39. What is the ratio of the Value added (constant 2005 US$) of 1963 in Bangladesh to that in China?
Your response must be concise. 0.37. What is the ratio of the Value added (constant 2005 US$) of 1960 in Bangladesh to that in Congo (Republic)?
Your response must be concise. 26.07. What is the ratio of the Value added (constant 2005 US$) in 1961 in Bangladesh to that in Congo (Republic)?
Your answer should be very brief. 24.99. What is the ratio of the Value added (constant 2005 US$) in 1962 in Bangladesh to that in Congo (Republic)?
Make the answer very short. 23.42. What is the ratio of the Value added (constant 2005 US$) of 1963 in Bangladesh to that in Congo (Republic)?
Provide a short and direct response. 25.08. What is the ratio of the Value added (constant 2005 US$) in 1960 in Bangladesh to that in Costa Rica?
Ensure brevity in your answer.  5.06. What is the ratio of the Value added (constant 2005 US$) of 1961 in Bangladesh to that in Costa Rica?
Make the answer very short. 5.63. What is the ratio of the Value added (constant 2005 US$) of 1962 in Bangladesh to that in Costa Rica?
Provide a succinct answer. 5.19. What is the ratio of the Value added (constant 2005 US$) in 1963 in Bangladesh to that in Costa Rica?
Your answer should be compact. 4.96. What is the ratio of the Value added (constant 2005 US$) in 1960 in Botswana to that in Chile?
Offer a terse response. 0.01. What is the ratio of the Value added (constant 2005 US$) of 1961 in Botswana to that in Chile?
Offer a very short reply. 0.01. What is the ratio of the Value added (constant 2005 US$) in 1962 in Botswana to that in Chile?
Provide a succinct answer. 0.01. What is the ratio of the Value added (constant 2005 US$) of 1963 in Botswana to that in Chile?
Make the answer very short. 0.01. What is the ratio of the Value added (constant 2005 US$) of 1960 in Botswana to that in China?
Provide a succinct answer. 0. What is the ratio of the Value added (constant 2005 US$) of 1961 in Botswana to that in China?
Provide a succinct answer. 0.01. What is the ratio of the Value added (constant 2005 US$) of 1962 in Botswana to that in China?
Keep it short and to the point. 0.01. What is the ratio of the Value added (constant 2005 US$) of 1963 in Botswana to that in China?
Ensure brevity in your answer.  0.01. What is the ratio of the Value added (constant 2005 US$) of 1960 in Botswana to that in Congo (Republic)?
Offer a very short reply. 0.37. What is the ratio of the Value added (constant 2005 US$) of 1961 in Botswana to that in Congo (Republic)?
Provide a short and direct response. 0.36. What is the ratio of the Value added (constant 2005 US$) in 1962 in Botswana to that in Congo (Republic)?
Ensure brevity in your answer.  0.36. What is the ratio of the Value added (constant 2005 US$) of 1963 in Botswana to that in Congo (Republic)?
Provide a succinct answer. 0.42. What is the ratio of the Value added (constant 2005 US$) of 1960 in Botswana to that in Costa Rica?
Give a very brief answer. 0.07. What is the ratio of the Value added (constant 2005 US$) of 1961 in Botswana to that in Costa Rica?
Your answer should be very brief. 0.08. What is the ratio of the Value added (constant 2005 US$) of 1962 in Botswana to that in Costa Rica?
Your response must be concise. 0.08. What is the ratio of the Value added (constant 2005 US$) in 1963 in Botswana to that in Costa Rica?
Make the answer very short. 0.08. What is the ratio of the Value added (constant 2005 US$) in 1960 in Chile to that in China?
Your answer should be compact. 0.33. What is the ratio of the Value added (constant 2005 US$) of 1961 in Chile to that in China?
Offer a very short reply. 0.47. What is the ratio of the Value added (constant 2005 US$) of 1962 in Chile to that in China?
Offer a very short reply. 0.52. What is the ratio of the Value added (constant 2005 US$) of 1963 in Chile to that in China?
Provide a succinct answer. 0.53. What is the ratio of the Value added (constant 2005 US$) of 1960 in Chile to that in Congo (Republic)?
Offer a terse response. 36.04. What is the ratio of the Value added (constant 2005 US$) of 1961 in Chile to that in Congo (Republic)?
Give a very brief answer. 33.4. What is the ratio of the Value added (constant 2005 US$) of 1962 in Chile to that in Congo (Republic)?
Offer a terse response. 31.68. What is the ratio of the Value added (constant 2005 US$) of 1963 in Chile to that in Congo (Republic)?
Your answer should be very brief. 35.53. What is the ratio of the Value added (constant 2005 US$) in 1960 in Chile to that in Costa Rica?
Your response must be concise. 7. What is the ratio of the Value added (constant 2005 US$) in 1961 in Chile to that in Costa Rica?
Make the answer very short. 7.52. What is the ratio of the Value added (constant 2005 US$) in 1962 in Chile to that in Costa Rica?
Offer a very short reply. 7.02. What is the ratio of the Value added (constant 2005 US$) of 1963 in Chile to that in Costa Rica?
Provide a short and direct response. 7.02. What is the ratio of the Value added (constant 2005 US$) in 1960 in China to that in Congo (Republic)?
Offer a terse response. 108.51. What is the ratio of the Value added (constant 2005 US$) in 1961 in China to that in Congo (Republic)?
Your answer should be very brief. 71.73. What is the ratio of the Value added (constant 2005 US$) in 1962 in China to that in Congo (Republic)?
Your response must be concise. 60.67. What is the ratio of the Value added (constant 2005 US$) in 1963 in China to that in Congo (Republic)?
Your response must be concise. 67.39. What is the ratio of the Value added (constant 2005 US$) in 1960 in China to that in Costa Rica?
Make the answer very short. 21.08. What is the ratio of the Value added (constant 2005 US$) of 1961 in China to that in Costa Rica?
Your answer should be very brief. 16.15. What is the ratio of the Value added (constant 2005 US$) of 1962 in China to that in Costa Rica?
Give a very brief answer. 13.45. What is the ratio of the Value added (constant 2005 US$) of 1963 in China to that in Costa Rica?
Provide a succinct answer. 13.32. What is the ratio of the Value added (constant 2005 US$) in 1960 in Congo (Republic) to that in Costa Rica?
Provide a succinct answer. 0.19. What is the ratio of the Value added (constant 2005 US$) in 1961 in Congo (Republic) to that in Costa Rica?
Provide a short and direct response. 0.23. What is the ratio of the Value added (constant 2005 US$) in 1962 in Congo (Republic) to that in Costa Rica?
Provide a succinct answer. 0.22. What is the ratio of the Value added (constant 2005 US$) in 1963 in Congo (Republic) to that in Costa Rica?
Your answer should be compact. 0.2. What is the difference between the highest and the second highest Value added (constant 2005 US$) in 1960?
Provide a short and direct response. 2.19e+1. What is the difference between the highest and the second highest Value added (constant 2005 US$) in 1961?
Offer a terse response. 1.30e+1. What is the difference between the highest and the second highest Value added (constant 2005 US$) in 1962?
Offer a very short reply. 1.05e+1. What is the difference between the highest and the second highest Value added (constant 2005 US$) in 1963?
Ensure brevity in your answer.  1.09e+1. What is the difference between the highest and the lowest Value added (constant 2005 US$) of 1960?
Your answer should be very brief. 3.26e+1. What is the difference between the highest and the lowest Value added (constant 2005 US$) of 1961?
Offer a terse response. 2.42e+1. What is the difference between the highest and the lowest Value added (constant 2005 US$) of 1962?
Offer a very short reply. 2.19e+1. What is the difference between the highest and the lowest Value added (constant 2005 US$) in 1963?
Provide a short and direct response. 2.29e+1. 